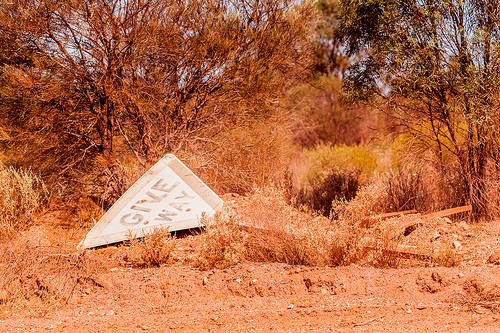<image>
Is there a sign above the ground? No. The sign is not positioned above the ground. The vertical arrangement shows a different relationship. 